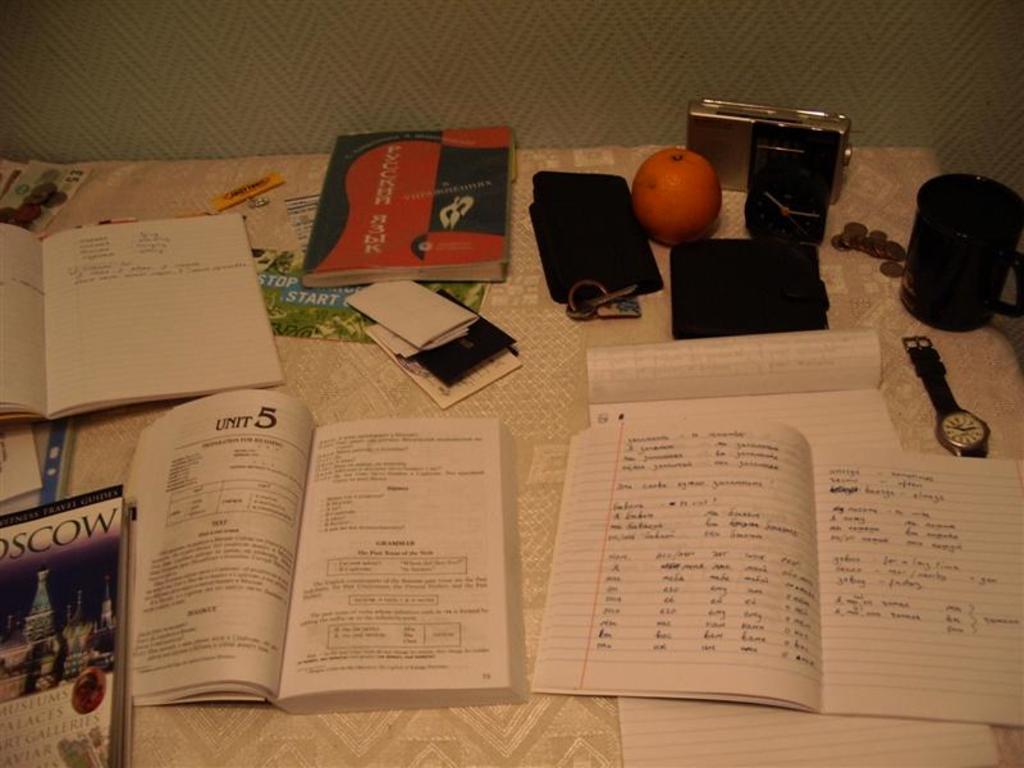What unit is the book turned to?
Make the answer very short. 5. 